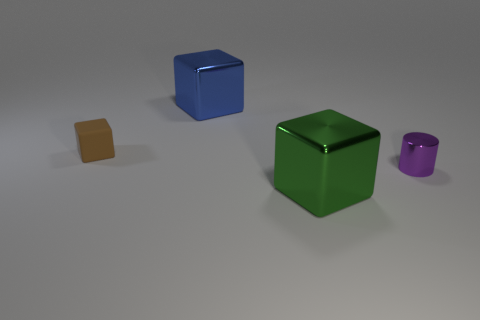Subtract all big blue metal blocks. How many blocks are left? 2 Subtract all brown cubes. How many cubes are left? 2 Subtract all gray cubes. How many gray cylinders are left? 0 Subtract all blue metallic things. Subtract all large cylinders. How many objects are left? 3 Add 1 big green objects. How many big green objects are left? 2 Add 3 cyan metal cylinders. How many cyan metal cylinders exist? 3 Add 1 big purple matte spheres. How many objects exist? 5 Subtract 0 red cylinders. How many objects are left? 4 Subtract all cubes. How many objects are left? 1 Subtract 1 cylinders. How many cylinders are left? 0 